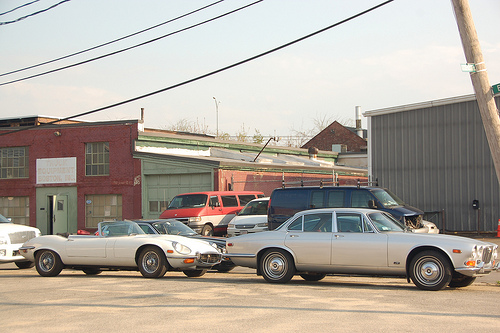<image>
Is there a white van in front of the fence? Yes. The white van is positioned in front of the fence, appearing closer to the camera viewpoint. 